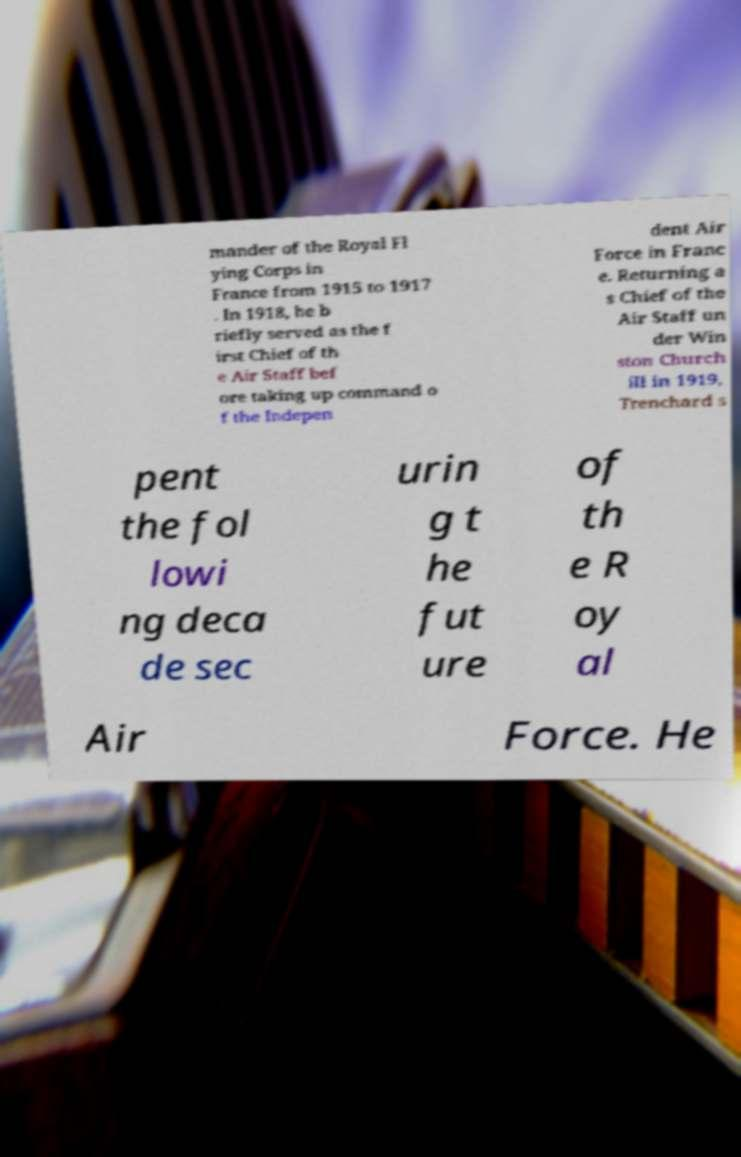What messages or text are displayed in this image? I need them in a readable, typed format. mander of the Royal Fl ying Corps in France from 1915 to 1917 . In 1918, he b riefly served as the f irst Chief of th e Air Staff bef ore taking up command o f the Indepen dent Air Force in Franc e. Returning a s Chief of the Air Staff un der Win ston Church ill in 1919, Trenchard s pent the fol lowi ng deca de sec urin g t he fut ure of th e R oy al Air Force. He 